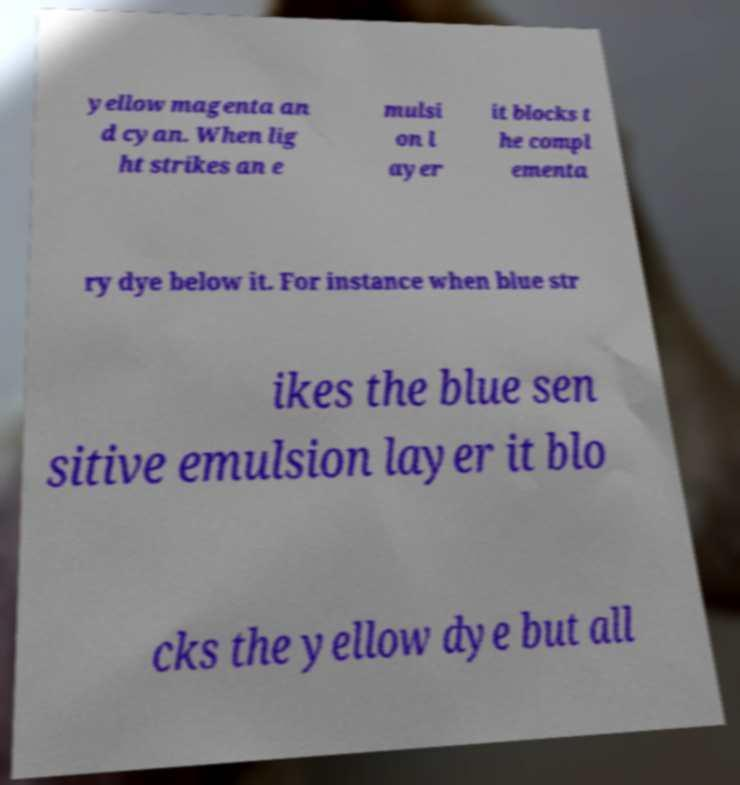There's text embedded in this image that I need extracted. Can you transcribe it verbatim? yellow magenta an d cyan. When lig ht strikes an e mulsi on l ayer it blocks t he compl ementa ry dye below it. For instance when blue str ikes the blue sen sitive emulsion layer it blo cks the yellow dye but all 